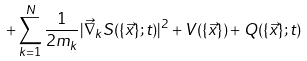<formula> <loc_0><loc_0><loc_500><loc_500>+ \sum _ { k = 1 } ^ { N } \frac { 1 } { 2 m _ { k } } | \vec { \nabla } _ { k } S ( \{ \vec { x } \} ; t ) | ^ { 2 } + V ( \{ \vec { x } \} ) + Q ( \{ \vec { x } \} ; t )</formula> 